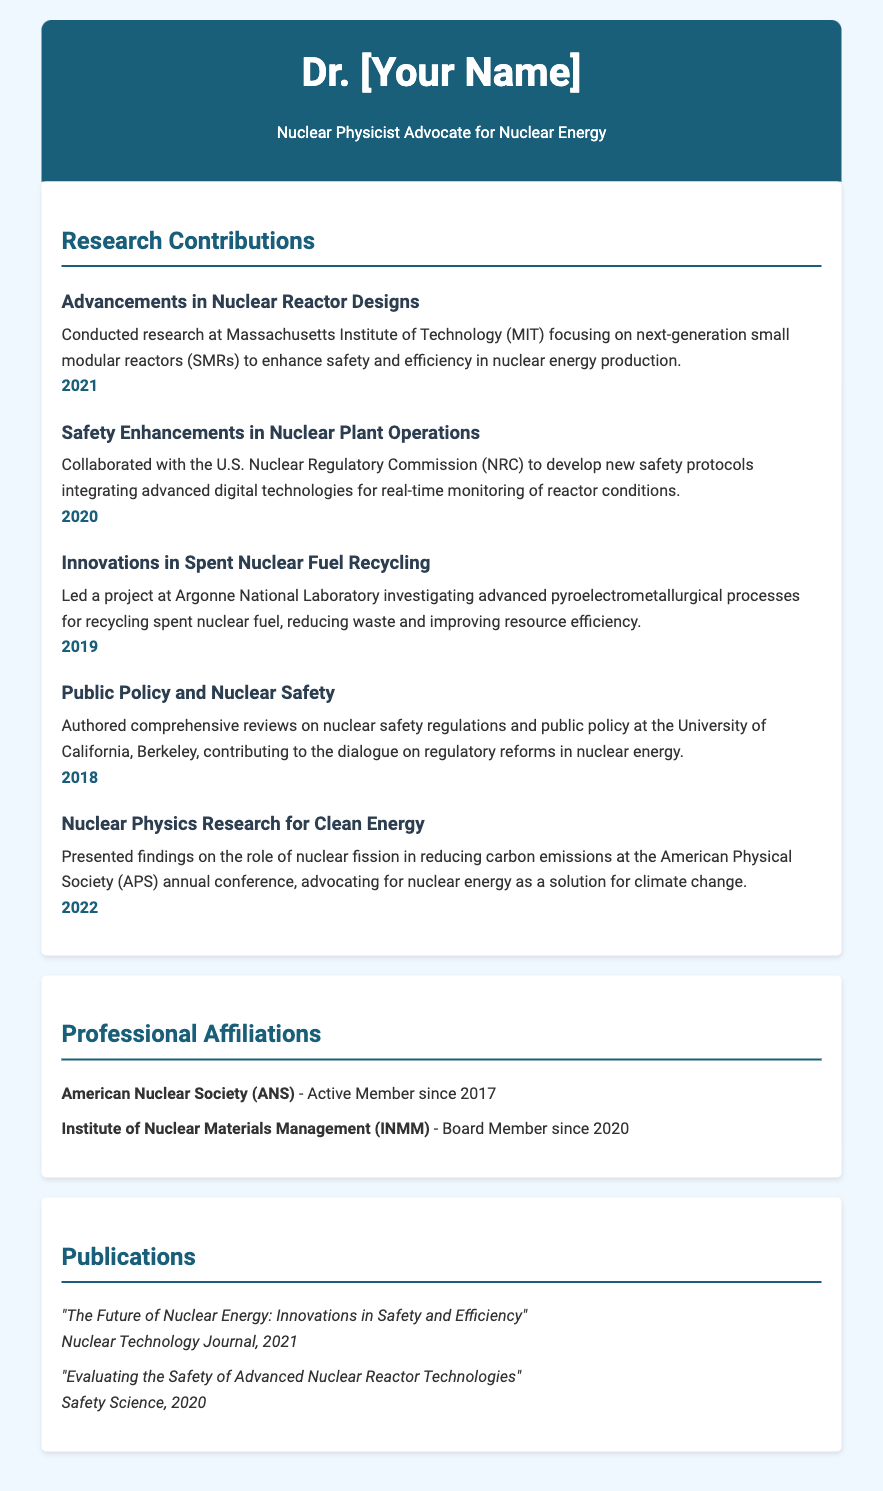What organization did Dr. [Your Name] collaborate with for safety enhancements? The document states that Dr. [Your Name] collaborated with the U.S. Nuclear Regulatory Commission (NRC) for developing safety protocols.
Answer: U.S. Nuclear Regulatory Commission (NRC) What year was the research on small modular reactors conducted? The contribution related to small modular reactors mentions conducting research in 2021.
Answer: 2021 What is the key focus of the publication "Evaluating the Safety of Advanced Nuclear Reactor Technologies"? This publication title suggests it addresses the evaluation of safety pertaining to advanced nuclear reactor technologies, indicating its thematic focus.
Answer: Safety of Advanced Nuclear Reactor Technologies Who authored the reviews on nuclear safety regulations? The document mentions that Dr. [Your Name] authored comprehensive reviews on nuclear safety regulations, indicating their authorship.
Answer: Dr. [Your Name] What advanced process was investigated for recycling spent nuclear fuel? The document states that Dr. [Your Name] led a project investigating advanced pyroelectrometallurgical processes for spent nuclear fuel recycling.
Answer: Pyroelectrometallurgical processes What topic did Dr. [Your Name] present at the American Physical Society annual conference? The findings presented at the APS annual conference were about the role of nuclear fission in reducing carbon emissions.
Answer: Role of nuclear fission in reducing carbon emissions In which year did Dr. [Your Name] contribute to the dialogue on regulatory reforms in nuclear energy? The contribution related to regulatory reforms occurred in 2018, as indicated in the document.
Answer: 2018 What is the title of the publication that discusses innovations in safety and efficiency? The title discussing these innovations is "The Future of Nuclear Energy: Innovations in Safety and Efficiency."
Answer: The Future of Nuclear Energy: Innovations in Safety and Efficiency What is Dr. [Your Name]'s professional affiliation with the American Nuclear Society? The document indicates that Dr. [Your Name] has been an active member of the American Nuclear Society since 2017.
Answer: Active Member since 2017 